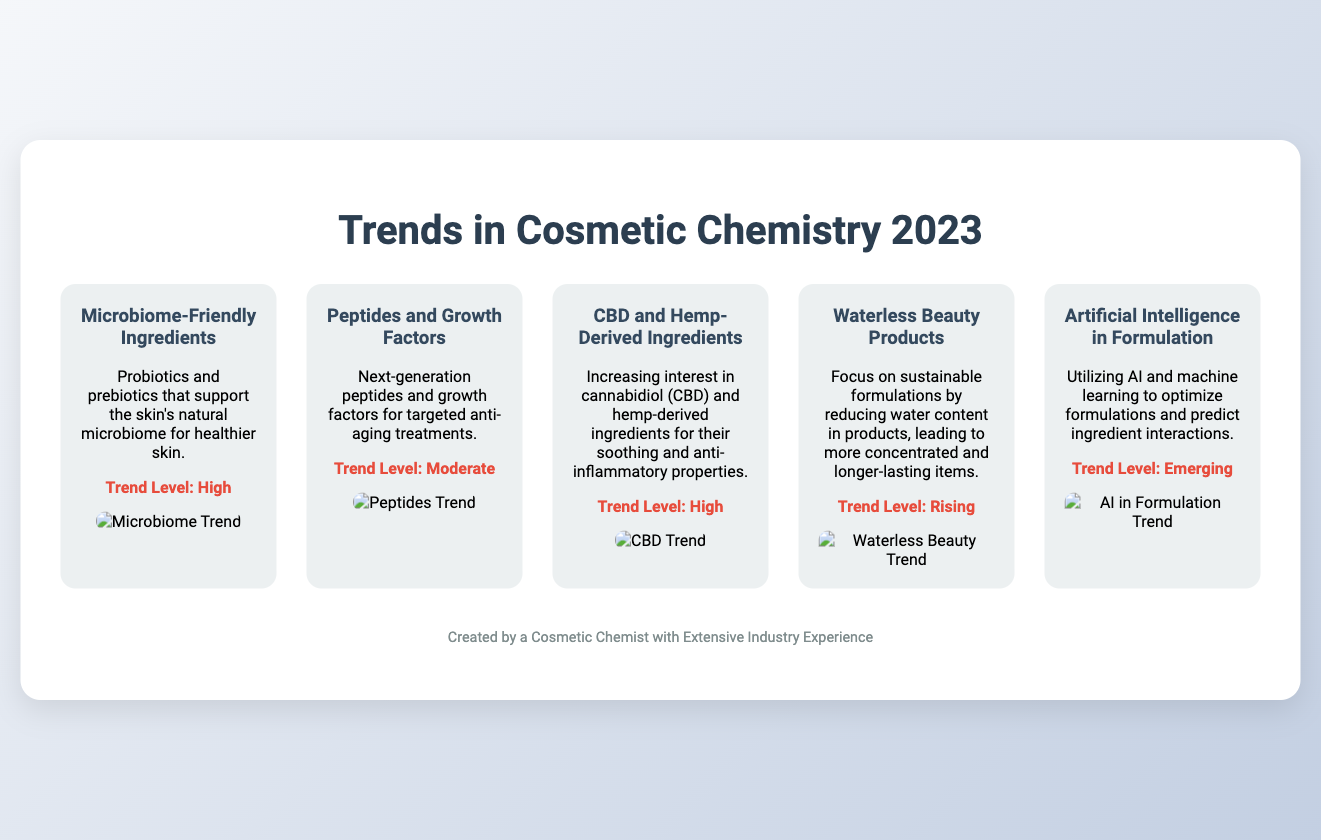What is the title of the poster? The title of the poster is the main heading displayed prominently at the top of the document.
Answer: Trends in Cosmetic Chemistry 2023 What is the trend level for Microbiome-Friendly Ingredients? The trend level indicates the popularity or importance of each trend within the document.
Answer: High Which innovative ingredient is noted for its soothing properties? This ingredient is highlighted for its multiple benefits, including being anti-inflammatory in nature.
Answer: CBD What concept is emphasized under the Waterless Beauty Products trend? The concept discusses the approach or focus of this trend as linked to sustainability in formulation.
Answer: Sustainable formulations How many trends are showcased in the document? This number represents the different specific trends presented on the poster.
Answer: Five What visual representation type is used for Waterless Beauty Products? The type of graphic shown alongside the description helps illustrate the trend's significance.
Answer: Heat Map Which new technology is mentioned for optimizing formulations? This technology represents the integration of modern advancements into cosmetic chemistry practices.
Answer: Artificial Intelligence 